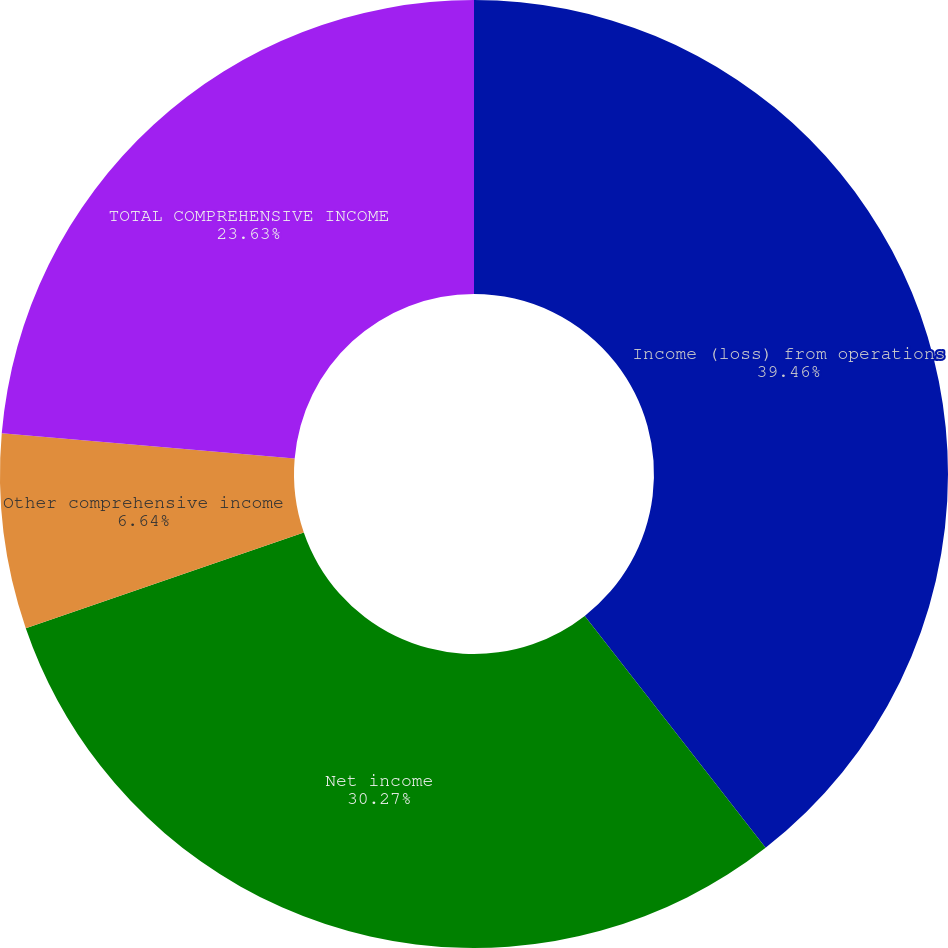Convert chart to OTSL. <chart><loc_0><loc_0><loc_500><loc_500><pie_chart><fcel>Income (loss) from operations<fcel>Net income<fcel>Other comprehensive income<fcel>TOTAL COMPREHENSIVE INCOME<nl><fcel>39.45%<fcel>30.27%<fcel>6.64%<fcel>23.63%<nl></chart> 